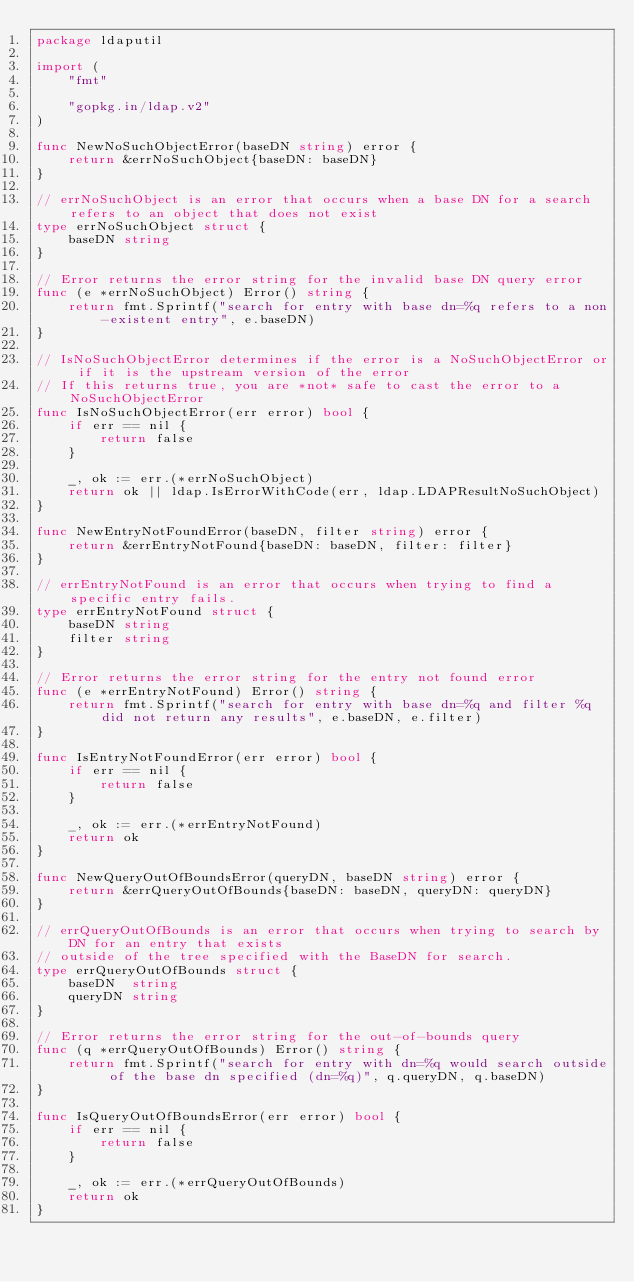<code> <loc_0><loc_0><loc_500><loc_500><_Go_>package ldaputil

import (
	"fmt"

	"gopkg.in/ldap.v2"
)

func NewNoSuchObjectError(baseDN string) error {
	return &errNoSuchObject{baseDN: baseDN}
}

// errNoSuchObject is an error that occurs when a base DN for a search refers to an object that does not exist
type errNoSuchObject struct {
	baseDN string
}

// Error returns the error string for the invalid base DN query error
func (e *errNoSuchObject) Error() string {
	return fmt.Sprintf("search for entry with base dn=%q refers to a non-existent entry", e.baseDN)
}

// IsNoSuchObjectError determines if the error is a NoSuchObjectError or if it is the upstream version of the error
// If this returns true, you are *not* safe to cast the error to a NoSuchObjectError
func IsNoSuchObjectError(err error) bool {
	if err == nil {
		return false
	}

	_, ok := err.(*errNoSuchObject)
	return ok || ldap.IsErrorWithCode(err, ldap.LDAPResultNoSuchObject)
}

func NewEntryNotFoundError(baseDN, filter string) error {
	return &errEntryNotFound{baseDN: baseDN, filter: filter}
}

// errEntryNotFound is an error that occurs when trying to find a specific entry fails.
type errEntryNotFound struct {
	baseDN string
	filter string
}

// Error returns the error string for the entry not found error
func (e *errEntryNotFound) Error() string {
	return fmt.Sprintf("search for entry with base dn=%q and filter %q did not return any results", e.baseDN, e.filter)
}

func IsEntryNotFoundError(err error) bool {
	if err == nil {
		return false
	}

	_, ok := err.(*errEntryNotFound)
	return ok
}

func NewQueryOutOfBoundsError(queryDN, baseDN string) error {
	return &errQueryOutOfBounds{baseDN: baseDN, queryDN: queryDN}
}

// errQueryOutOfBounds is an error that occurs when trying to search by DN for an entry that exists
// outside of the tree specified with the BaseDN for search.
type errQueryOutOfBounds struct {
	baseDN  string
	queryDN string
}

// Error returns the error string for the out-of-bounds query
func (q *errQueryOutOfBounds) Error() string {
	return fmt.Sprintf("search for entry with dn=%q would search outside of the base dn specified (dn=%q)", q.queryDN, q.baseDN)
}

func IsQueryOutOfBoundsError(err error) bool {
	if err == nil {
		return false
	}

	_, ok := err.(*errQueryOutOfBounds)
	return ok
}
</code> 